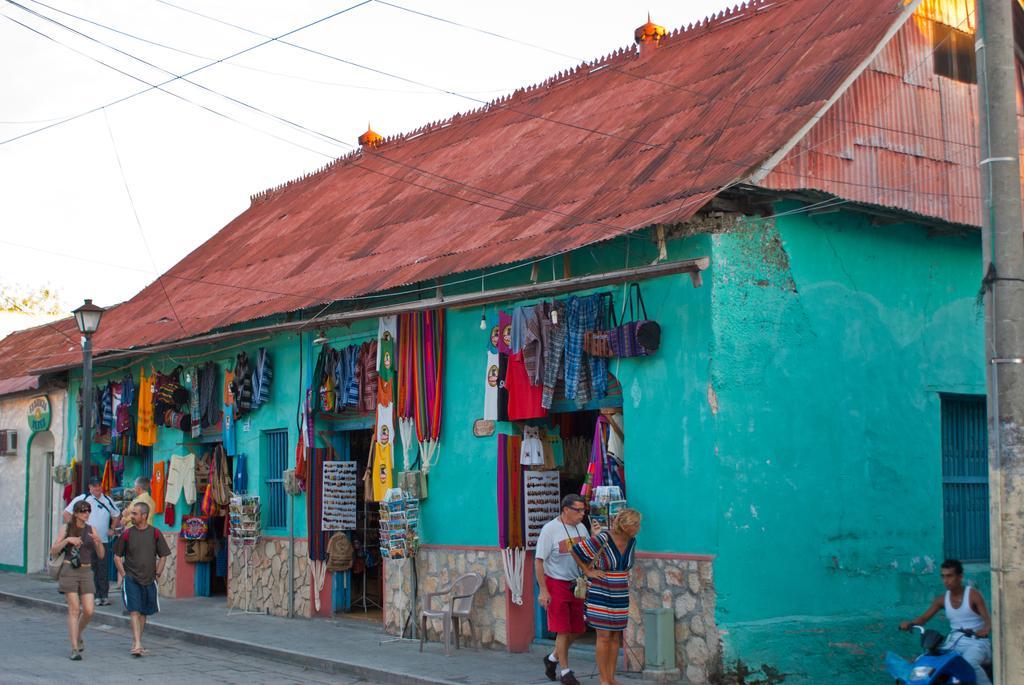Can you describe this image briefly? In the center of the image there are houses. There are clothes on the walls. There are people walking on the road. There is a light pole. At the top of the image there is sky, electric wires. To the right side of the image there is a pole. 